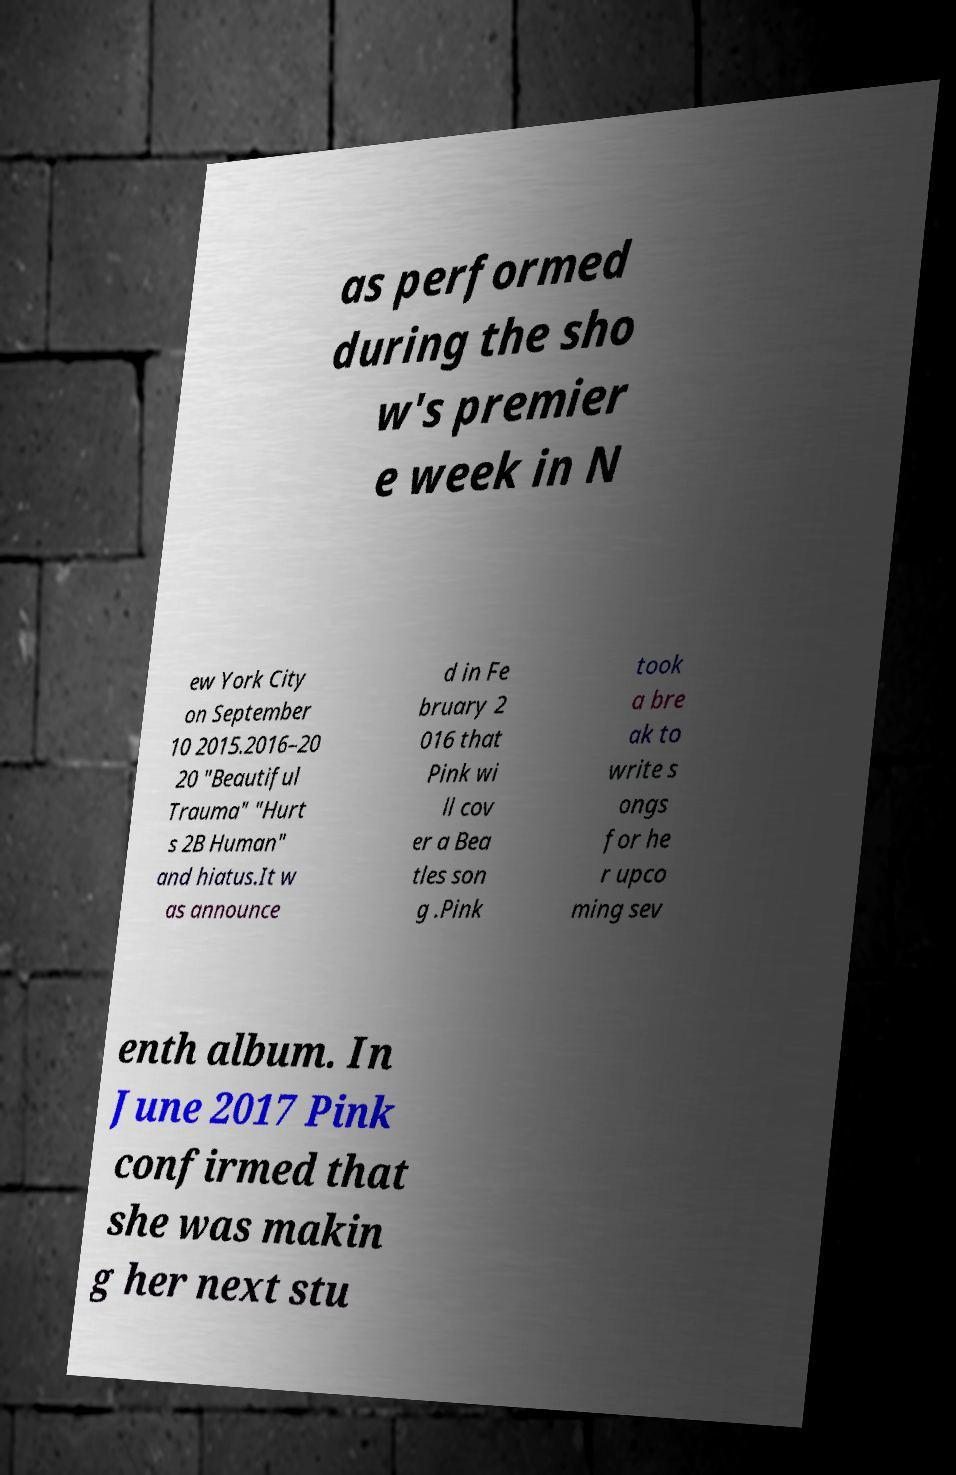Please identify and transcribe the text found in this image. as performed during the sho w's premier e week in N ew York City on September 10 2015.2016–20 20 "Beautiful Trauma" "Hurt s 2B Human" and hiatus.It w as announce d in Fe bruary 2 016 that Pink wi ll cov er a Bea tles son g .Pink took a bre ak to write s ongs for he r upco ming sev enth album. In June 2017 Pink confirmed that she was makin g her next stu 